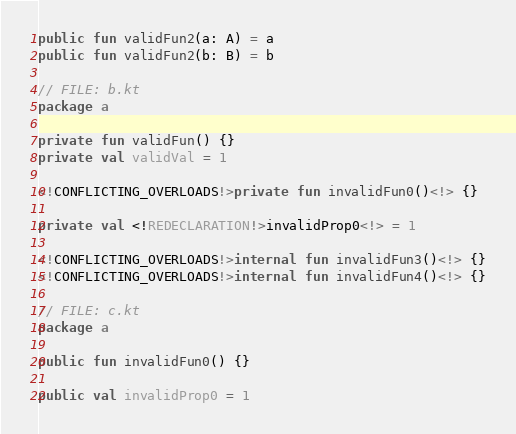<code> <loc_0><loc_0><loc_500><loc_500><_Kotlin_>public fun validFun2(a: A) = a
public fun validFun2(b: B) = b

// FILE: b.kt
package a

private fun validFun() {}
private val validVal = 1

<!CONFLICTING_OVERLOADS!>private fun invalidFun0()<!> {}

private val <!REDECLARATION!>invalidProp0<!> = 1

<!CONFLICTING_OVERLOADS!>internal fun invalidFun3()<!> {}
<!CONFLICTING_OVERLOADS!>internal fun invalidFun4()<!> {}

// FILE: c.kt
package a

public fun invalidFun0() {}

public val invalidProp0 = 1
</code> 